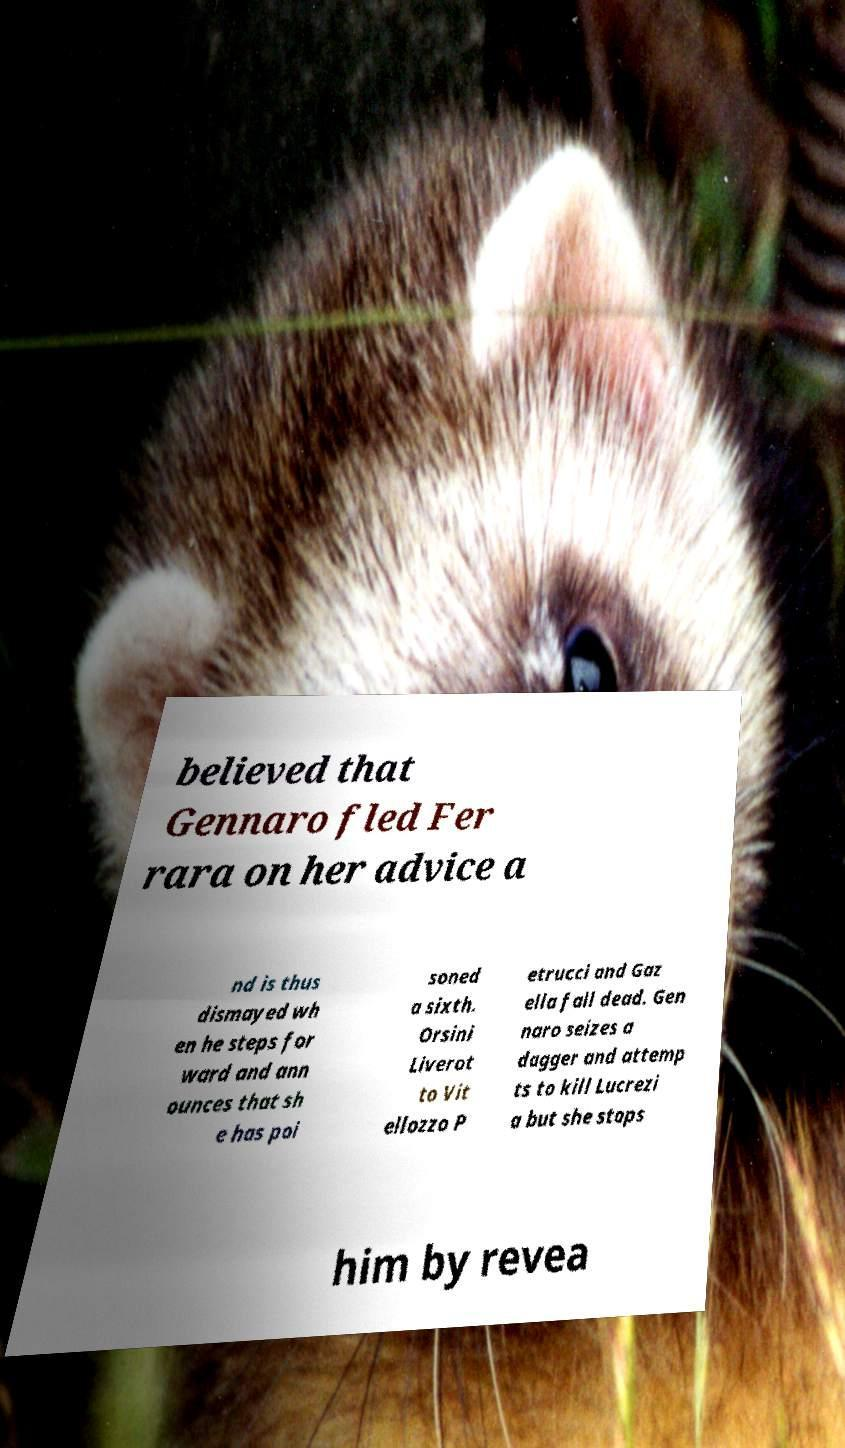Could you assist in decoding the text presented in this image and type it out clearly? believed that Gennaro fled Fer rara on her advice a nd is thus dismayed wh en he steps for ward and ann ounces that sh e has poi soned a sixth. Orsini Liverot to Vit ellozzo P etrucci and Gaz ella fall dead. Gen naro seizes a dagger and attemp ts to kill Lucrezi a but she stops him by revea 